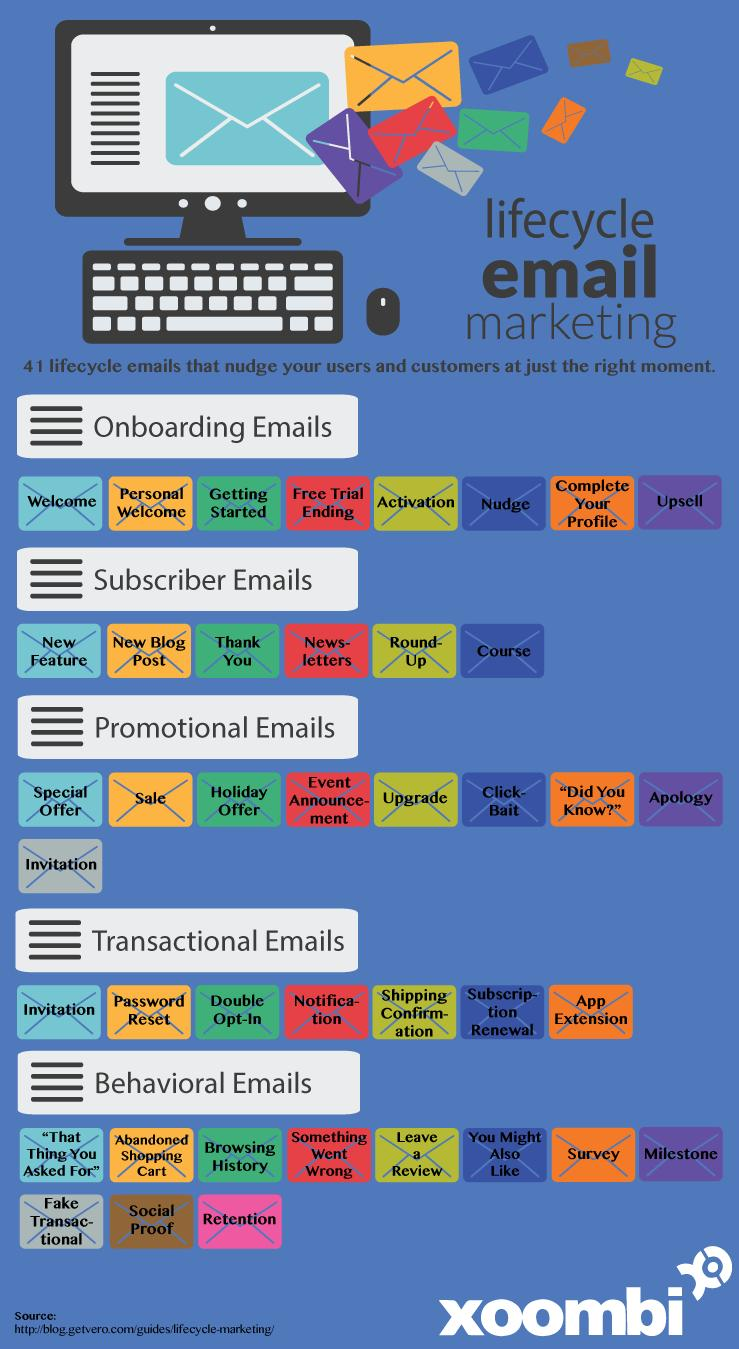Outline some significant characteristics in this image. The highest number of lifecycle emails falls under the category of behavioral emails. 8 envelopes are shown under onboarding emails. Activation emails are categorized as onboarding emails. Invitation emails can be categorized into two groups: promotional emails and transactional emails. Notification emails fall under the category of transactional emails. 